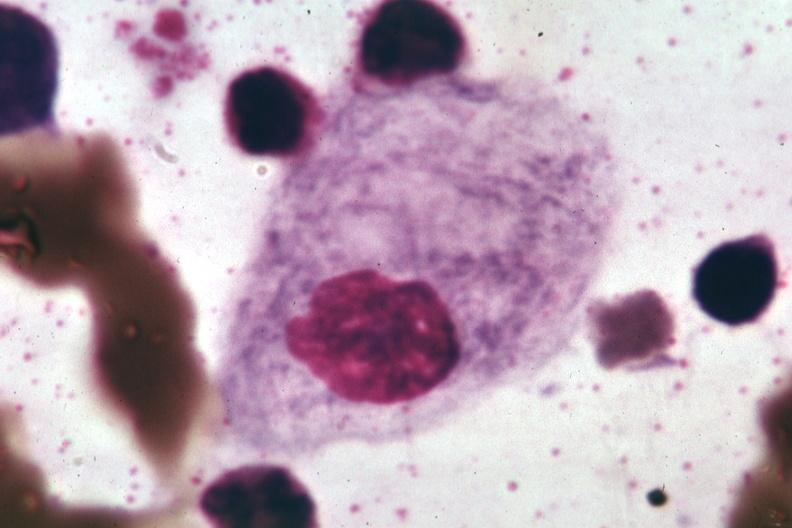s bone marrow present?
Answer the question using a single word or phrase. Yes 